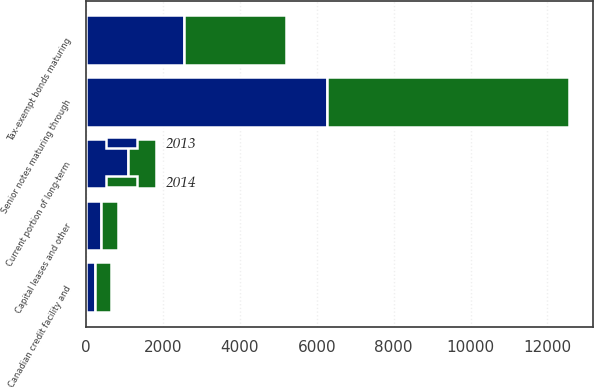Convert chart to OTSL. <chart><loc_0><loc_0><loc_500><loc_500><stacked_bar_chart><ecel><fcel>Canadian credit facility and<fcel>Senior notes maturing through<fcel>Tax-exempt bonds maturing<fcel>Capital leases and other<fcel>Current portion of long-term<nl><fcel>2013<fcel>232<fcel>6273<fcel>2541<fcel>389<fcel>1090<nl><fcel>2014<fcel>414<fcel>6287<fcel>2664<fcel>441<fcel>726<nl></chart> 